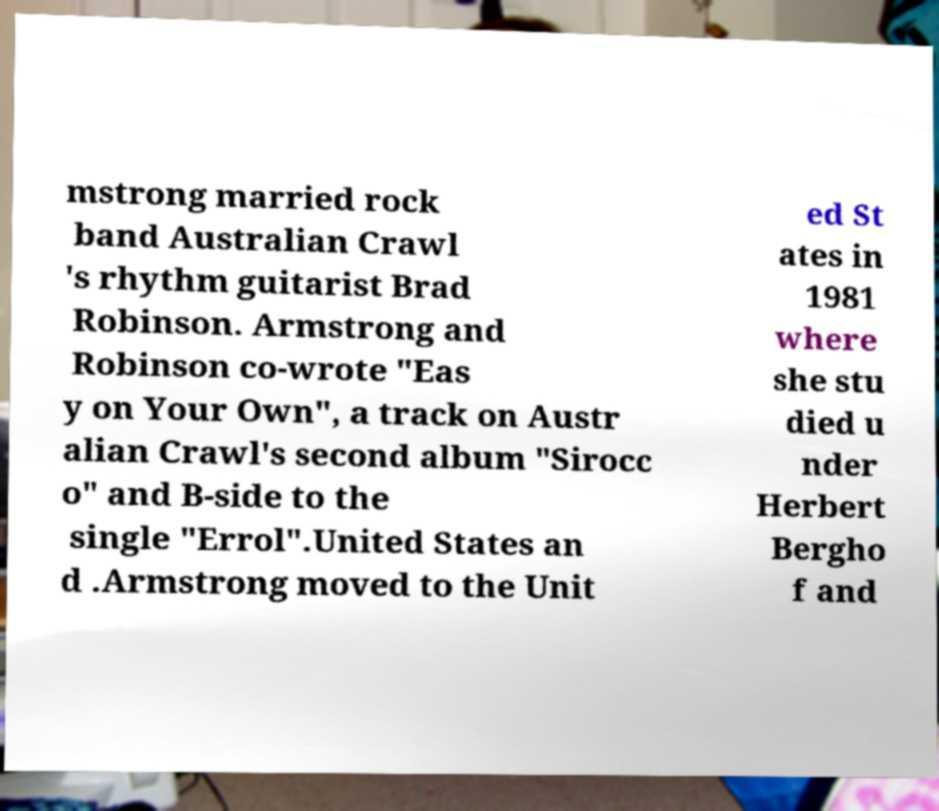Could you assist in decoding the text presented in this image and type it out clearly? mstrong married rock band Australian Crawl 's rhythm guitarist Brad Robinson. Armstrong and Robinson co-wrote "Eas y on Your Own", a track on Austr alian Crawl's second album "Sirocc o" and B-side to the single "Errol".United States an d .Armstrong moved to the Unit ed St ates in 1981 where she stu died u nder Herbert Bergho f and 